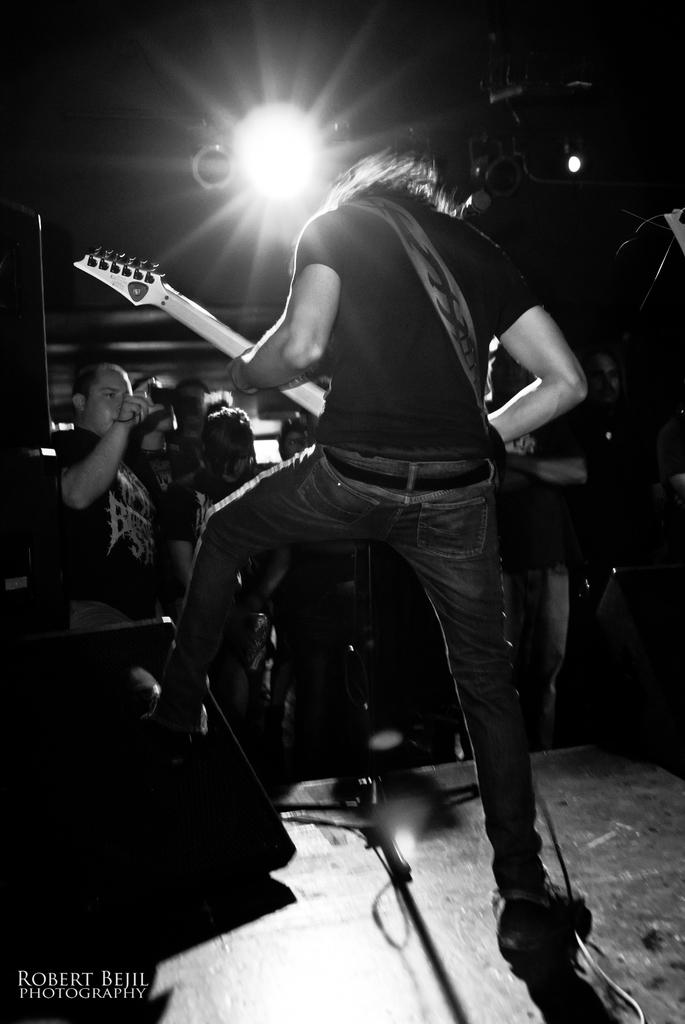What is the main subject of the image? There is a man standing at the center of the image. What is the man at the center holding? The man at the center is holding a guitar in his hand. Can you describe the other person in the image? There is another man in the background of the image, on the left side. What is the man in the background doing? The man in the background is capturing an image. What type of flower is the dad holding in the image? There is no dad or flower present in the image. How many sacks can be seen in the image? There are no sacks visible in the image. 